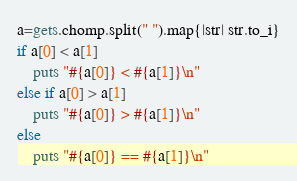Convert code to text. <code><loc_0><loc_0><loc_500><loc_500><_Ruby_>a=gets.chomp.split(" ").map{|str| str.to_i}
if a[0] < a[1]
	puts "#{a[0]} < #{a[1]}\n"
else if a[0] > a[1]
	puts "#{a[0]} > #{a[1]}\n"
else
	puts "#{a[0]} == #{a[1]}\n"</code> 